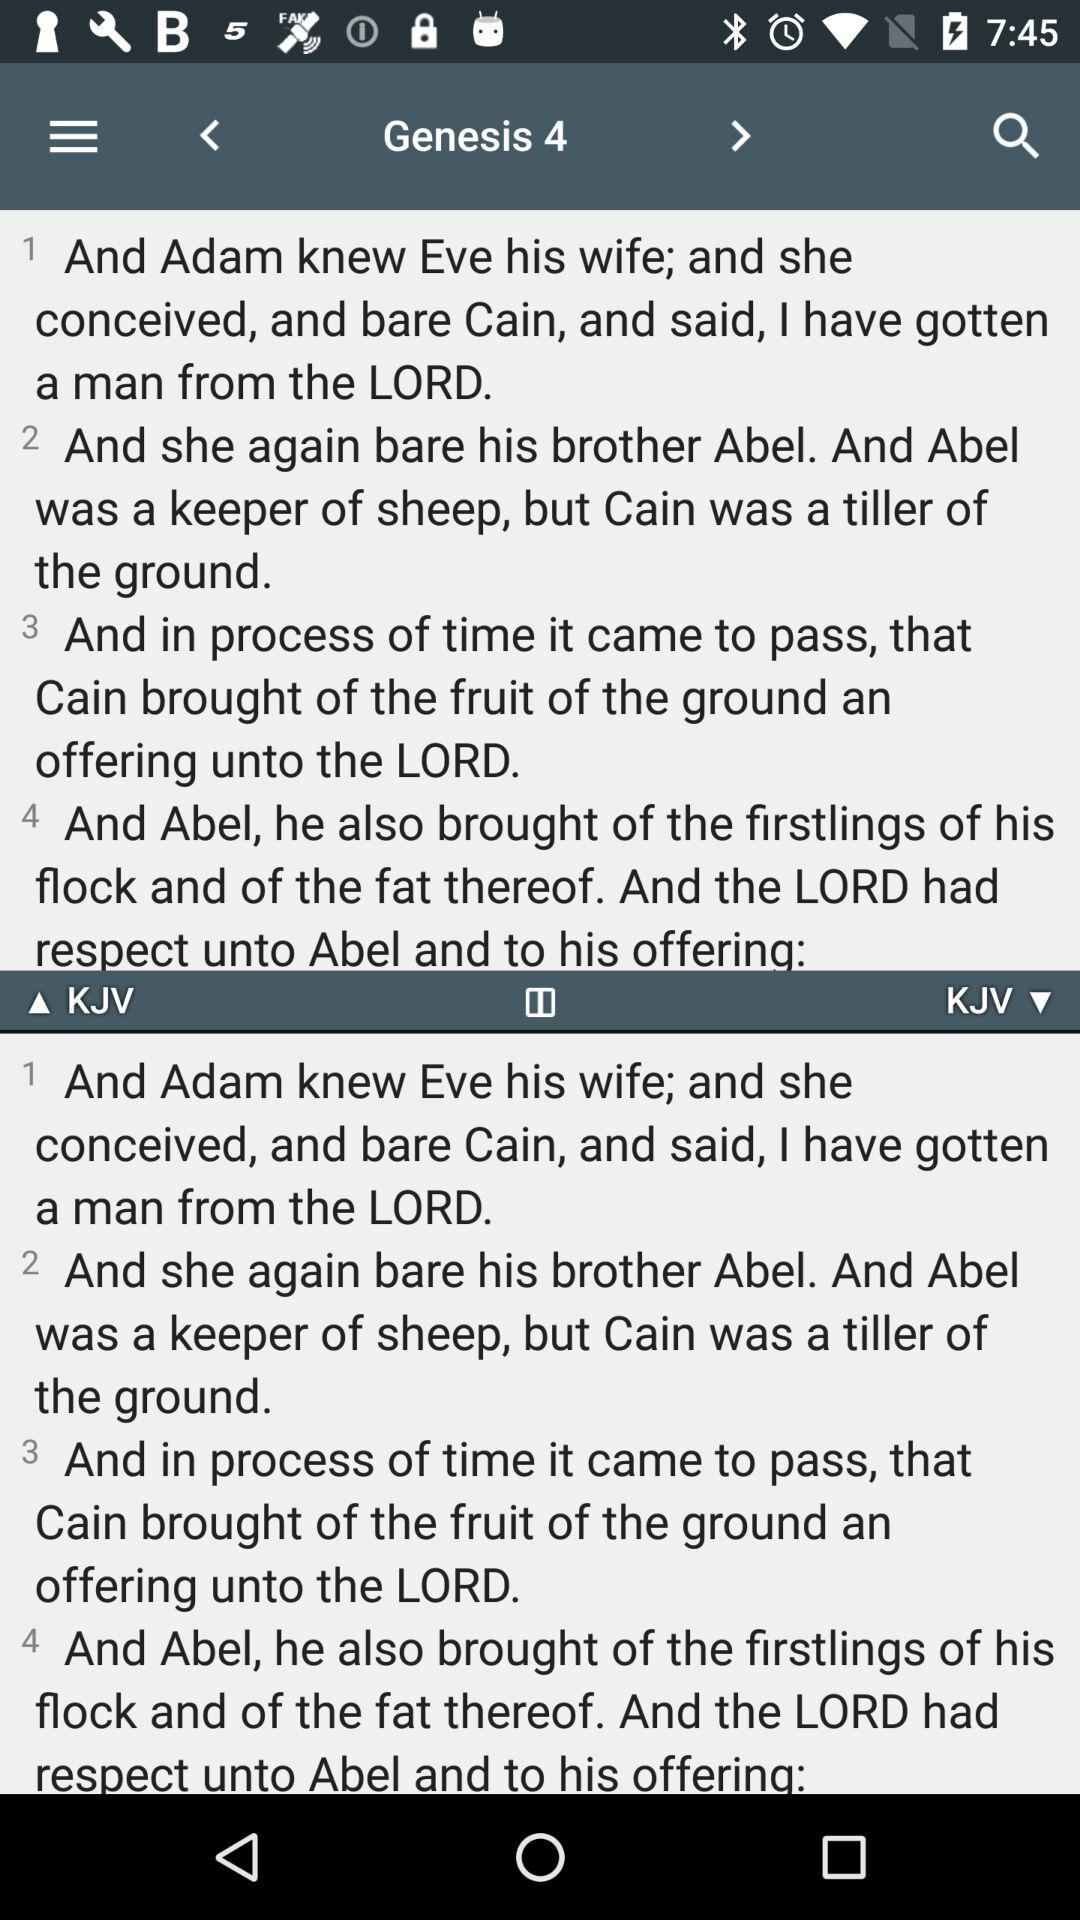How many chapters in Genesis are there in total?
When the provided information is insufficient, respond with <no answer>. <no answer> 